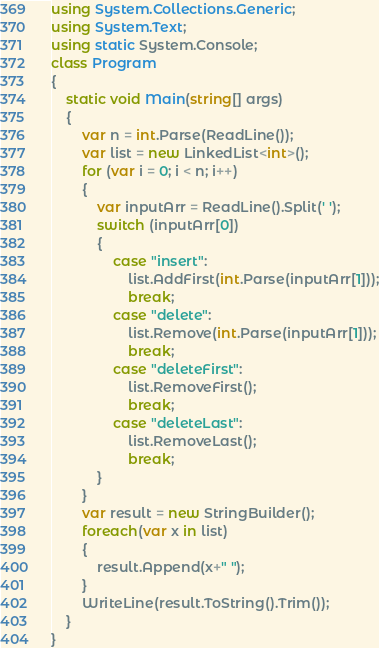Convert code to text. <code><loc_0><loc_0><loc_500><loc_500><_C#_>using System.Collections.Generic;
using System.Text;
using static System.Console;
class Program
{
    static void Main(string[] args)
    {
        var n = int.Parse(ReadLine());
        var list = new LinkedList<int>();
        for (var i = 0; i < n; i++)
        {
            var inputArr = ReadLine().Split(' ');
            switch (inputArr[0])
            {
                case "insert":
                    list.AddFirst(int.Parse(inputArr[1]));
                    break;
                case "delete":
                    list.Remove(int.Parse(inputArr[1]));
                    break;
                case "deleteFirst":
                    list.RemoveFirst();
                    break;
                case "deleteLast":
                    list.RemoveLast();
                    break;
            }
        }
        var result = new StringBuilder();
        foreach(var x in list)
        {
            result.Append(x+" ");
        }
        WriteLine(result.ToString().Trim());
    }
}
</code> 